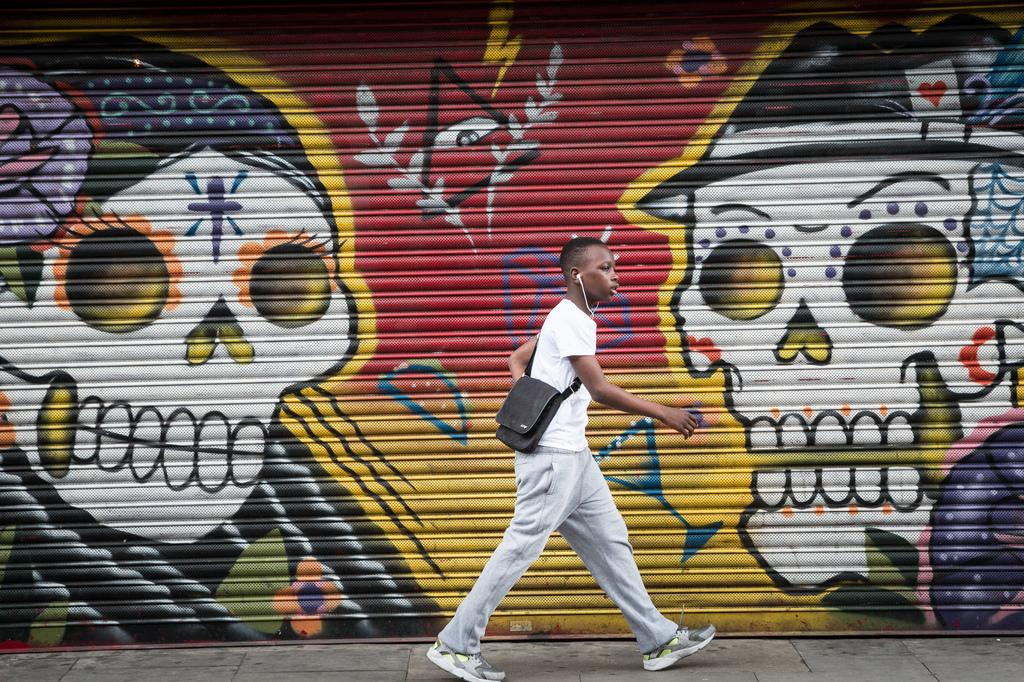Who is present in the image? There is a person in the image. What is the person wearing? The person is wearing a bag. What is the person doing in the image? The person is walking. What can be seen in the background of the image? There is a shutter in the background of the image. What is on the shutter? There is graffiti on the shutter. What type of question is being asked by the wren in the image? There is no wren present in the image, and therefore no question is being asked. 